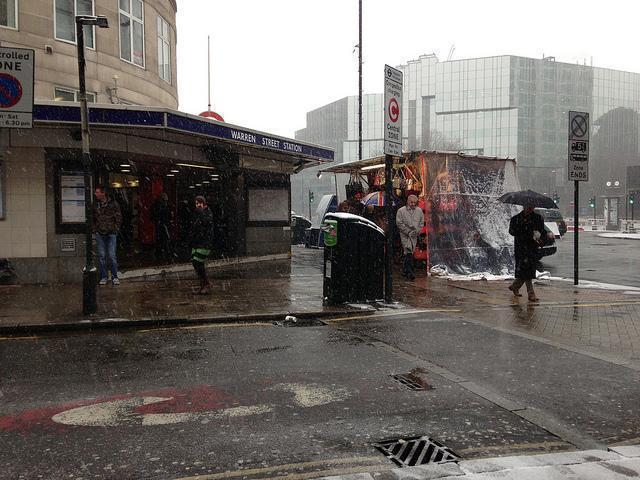What does the item the person on the far right is holding protect against?
Choose the right answer from the provided options to respond to the question.
Options: Rain, vampires, bears, mosquitos. Rain. 